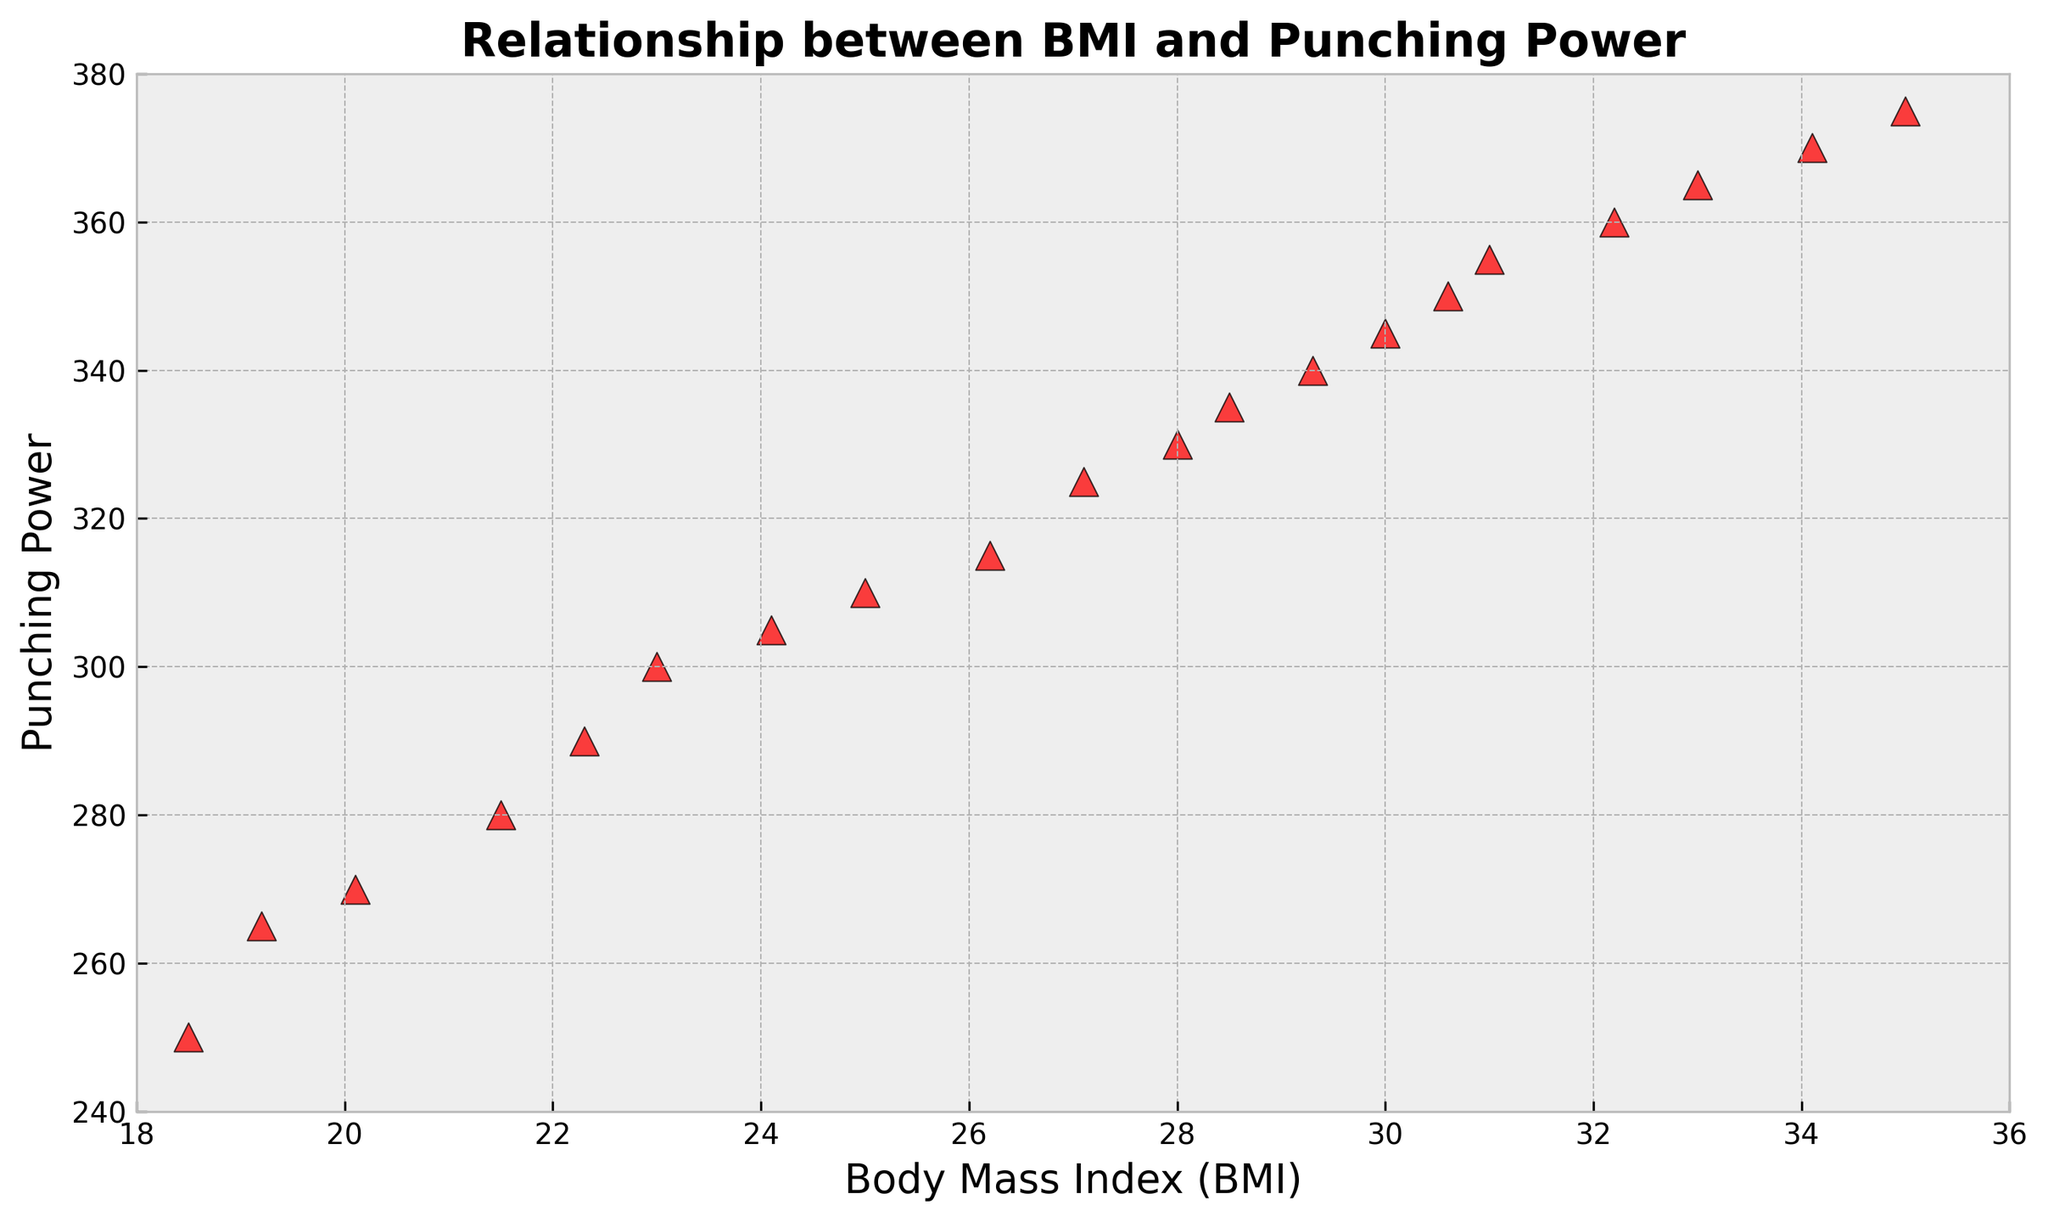What's the range of Punching Power values in the plot? To find the range, we subtract the minimum value of Punching Power from the maximum value. The minimum value is 250 and the maximum value is 375, thus the range is 375 - 250 = 125.
Answer: 125 What is the BMI value where the Punching Power is the highest? We find the data point with the highest Punching Power value in the scatter plot, which is 375. The corresponding BMI for this value is 35.0.
Answer: 35.0 Is there a linear trend between BMI and Punching Power? By looking at the scatter plot, we observe that as BMI increases, the Punching Power also tends to increase. This indicates a positive linear trend.
Answer: Yes What is the average Punching Power for BMI values between 25 and 30? First, identify the Punching Power values for BMI values between 25 and 30: 310, 315, 325, 330, 335, 340, 345. Sum these values and divide by the number of data points: (310 + 315 + 325 + 330 + 335 + 340 + 345) / 7 = 3300 / 7 ≈ 330.
Answer: 330 At what BMI do we see the steepest increase in Punching Power? To determine this, we look for the section of the plot with the most significant change in Punching Power over a short BMI interval. From 28.5 to 30.0 BMI, Punching Power increases from 335 to 345, which is a significant change.
Answer: Between 28.5 and 30.0 What's the difference in Punching Power between BMI 22.0 and BMI 30.0? First, locate the Punching Power values for these BMIs: BMI 22.3 has Punching Power 290 and BMI 30.0 has Punching Power 345. The difference is 345 - 290 = 55.
Answer: 55 Is there a data point that stands out as an outlier in terms of Punching Power? Outliers are data points that don't follow the general trend. Observing the plot, there is no specific point that significantly deviates from the overall trend, so no apparent outliers.
Answer: No What is the median Punching Power value shown in the plot? Arrange the Punching Power values in ascending order and find the middle one. With 20 values, the median is the average of the 10th and 11th values: (325 + 330) / 2 = 327.5.
Answer: 327.5 